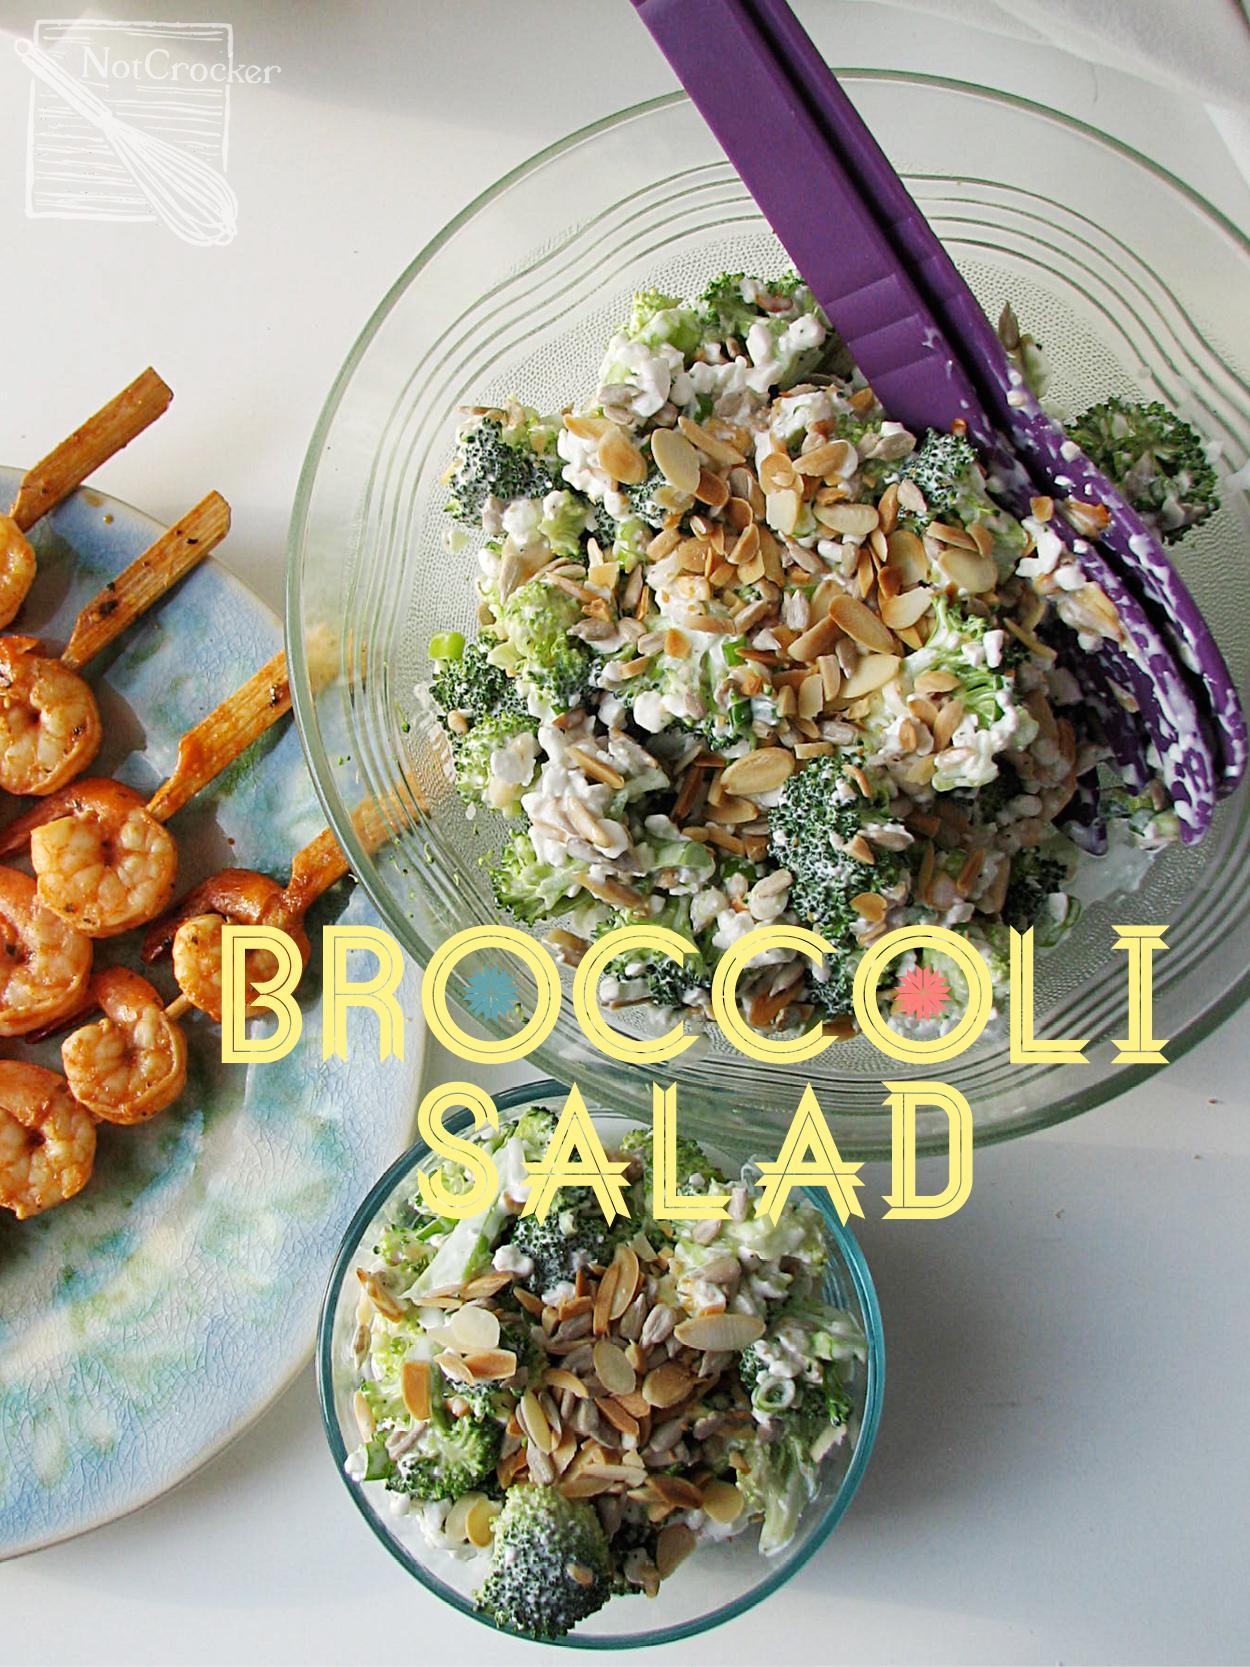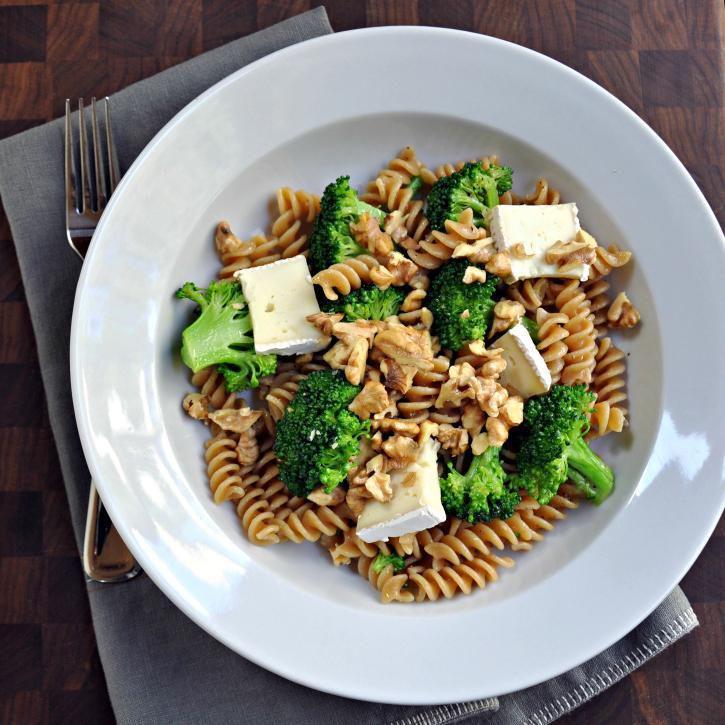The first image is the image on the left, the second image is the image on the right. For the images displayed, is the sentence "One of the dishes contains broccoli and spiral pasta." factually correct? Answer yes or no. Yes. The first image is the image on the left, the second image is the image on the right. Evaluate the accuracy of this statement regarding the images: "An image shows two silverware utensils on a white napkin next to a broccoli dish.". Is it true? Answer yes or no. No. 